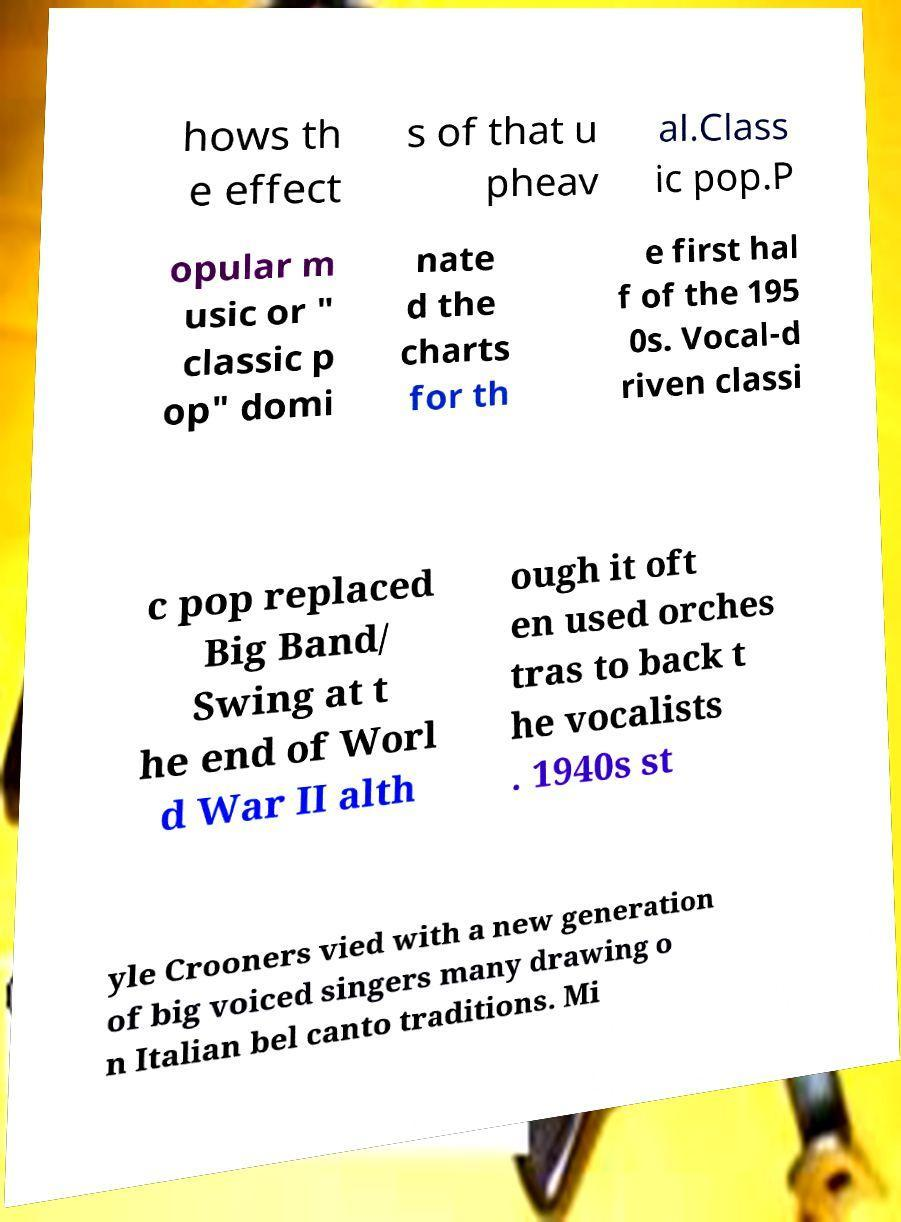I need the written content from this picture converted into text. Can you do that? hows th e effect s of that u pheav al.Class ic pop.P opular m usic or " classic p op" domi nate d the charts for th e first hal f of the 195 0s. Vocal-d riven classi c pop replaced Big Band/ Swing at t he end of Worl d War II alth ough it oft en used orches tras to back t he vocalists . 1940s st yle Crooners vied with a new generation of big voiced singers many drawing o n Italian bel canto traditions. Mi 